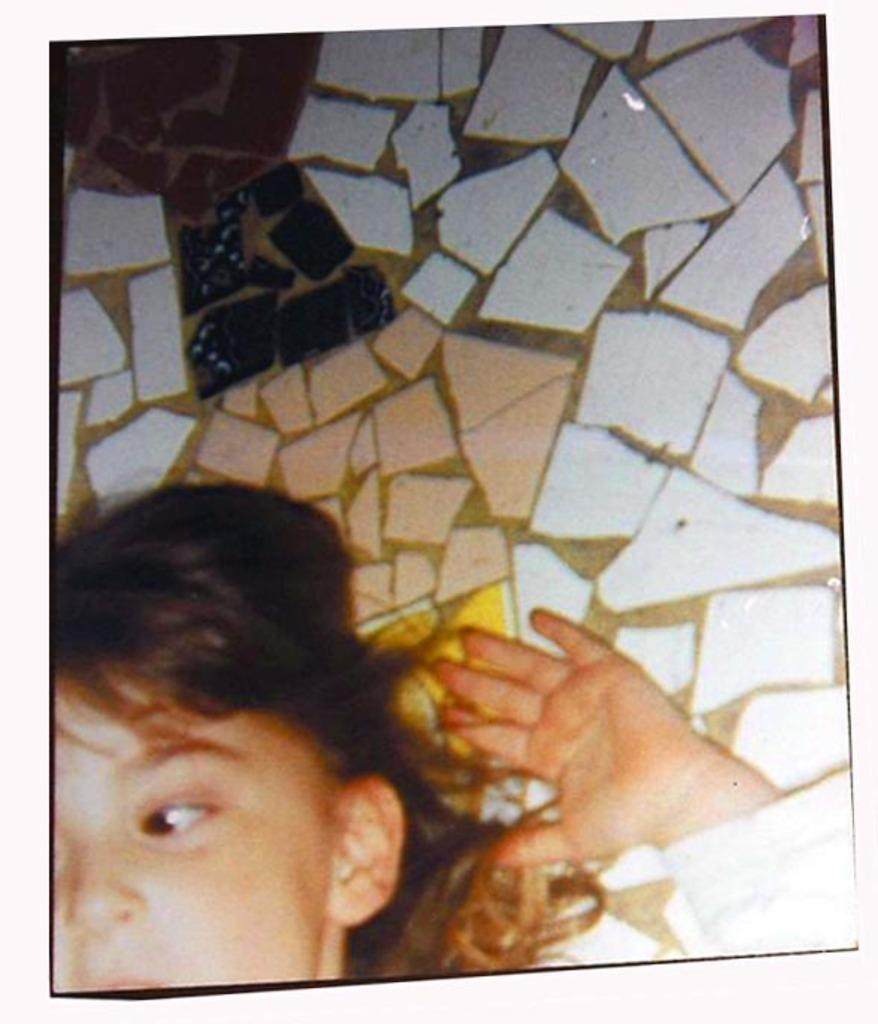Who is present in the image? There is a girl in the image. Where is the girl located in the image? The girl is at the bottom of the image. What type of poison is the girl holding in the image? There is no poison present in the image; the girl is not holding anything. What type of beast can be seen in the image? There is no beast present in the image; it only features a girl and a wall in the background. 